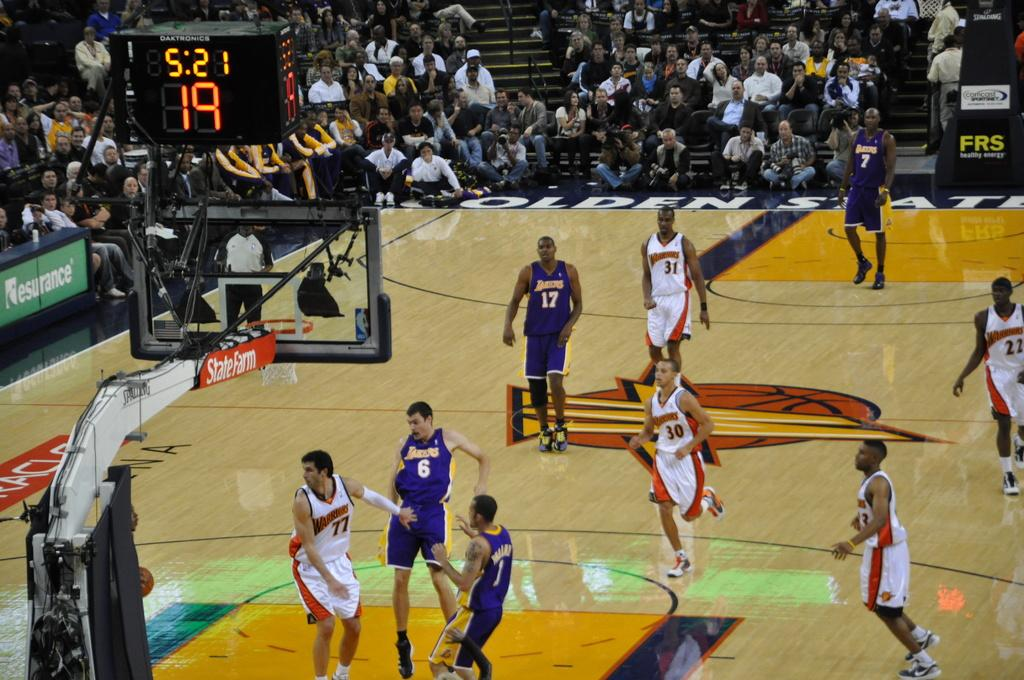<image>
Offer a succinct explanation of the picture presented. The Warriors are playing against the Lakers with five minutes and twenty one seconds left on the clock. 